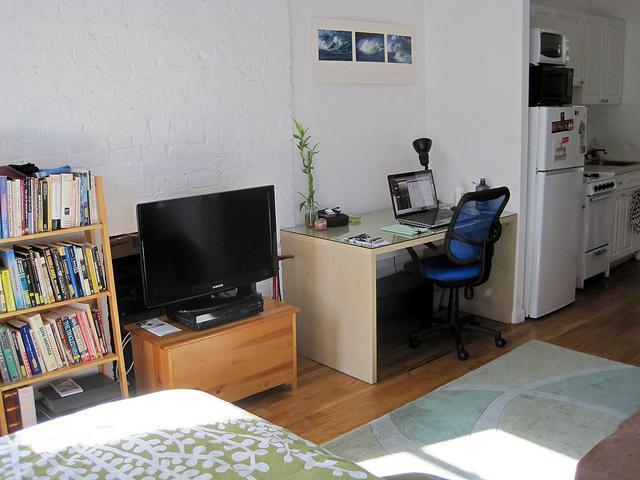How many people have on white shorts?
Give a very brief answer. 0. 